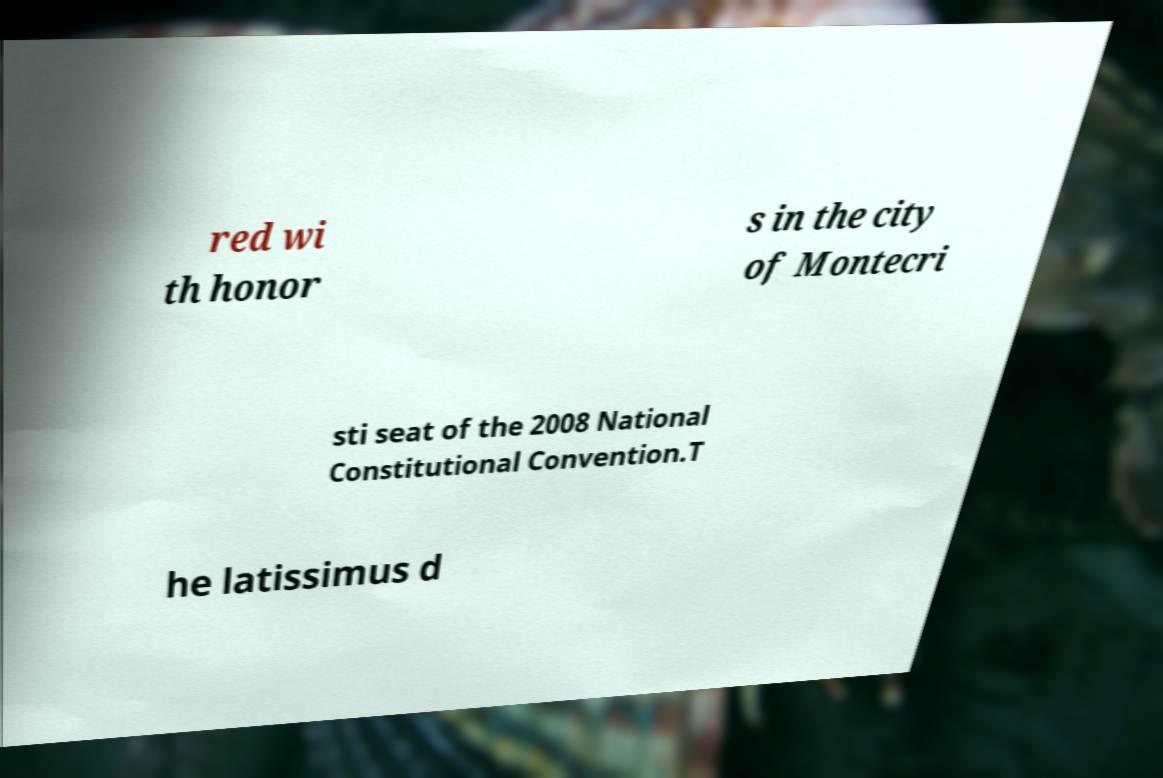Can you accurately transcribe the text from the provided image for me? red wi th honor s in the city of Montecri sti seat of the 2008 National Constitutional Convention.T he latissimus d 